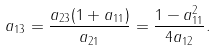<formula> <loc_0><loc_0><loc_500><loc_500>a _ { 1 3 } = \frac { a _ { 2 3 } ( 1 + a _ { 1 1 } ) } { a _ { 2 1 } } = \frac { 1 - a _ { 1 1 } ^ { 2 } } { 4 a _ { 1 2 } } .</formula> 